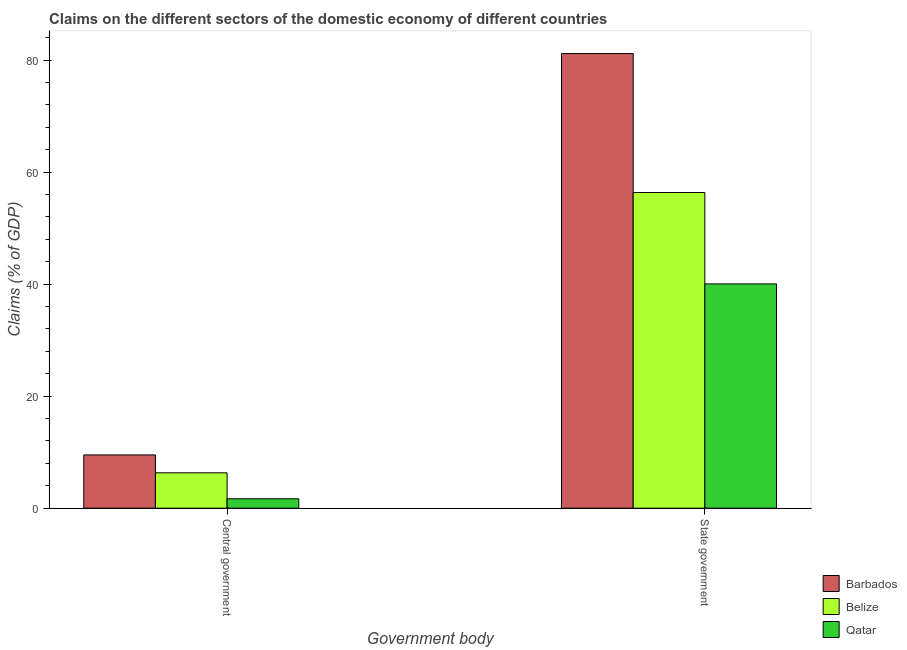Are the number of bars per tick equal to the number of legend labels?
Your answer should be very brief. Yes. How many bars are there on the 2nd tick from the right?
Make the answer very short. 3. What is the label of the 1st group of bars from the left?
Your answer should be very brief. Central government. What is the claims on central government in Qatar?
Ensure brevity in your answer.  1.68. Across all countries, what is the maximum claims on central government?
Your answer should be very brief. 9.51. Across all countries, what is the minimum claims on central government?
Your answer should be compact. 1.68. In which country was the claims on central government maximum?
Keep it short and to the point. Barbados. In which country was the claims on central government minimum?
Keep it short and to the point. Qatar. What is the total claims on state government in the graph?
Offer a terse response. 177.59. What is the difference between the claims on central government in Belize and that in Qatar?
Make the answer very short. 4.64. What is the difference between the claims on central government in Belize and the claims on state government in Barbados?
Your answer should be very brief. -74.86. What is the average claims on central government per country?
Ensure brevity in your answer.  5.84. What is the difference between the claims on state government and claims on central government in Qatar?
Ensure brevity in your answer.  38.37. In how many countries, is the claims on central government greater than 20 %?
Provide a succinct answer. 0. What is the ratio of the claims on state government in Barbados to that in Qatar?
Provide a succinct answer. 2.03. Is the claims on central government in Belize less than that in Qatar?
Ensure brevity in your answer.  No. What does the 1st bar from the left in Central government represents?
Provide a succinct answer. Barbados. What does the 3rd bar from the right in Central government represents?
Keep it short and to the point. Barbados. How many bars are there?
Offer a very short reply. 6. Are all the bars in the graph horizontal?
Your response must be concise. No. What is the difference between two consecutive major ticks on the Y-axis?
Give a very brief answer. 20. Are the values on the major ticks of Y-axis written in scientific E-notation?
Provide a short and direct response. No. Does the graph contain any zero values?
Your response must be concise. No. Where does the legend appear in the graph?
Ensure brevity in your answer.  Bottom right. How many legend labels are there?
Provide a short and direct response. 3. What is the title of the graph?
Your response must be concise. Claims on the different sectors of the domestic economy of different countries. Does "St. Vincent and the Grenadines" appear as one of the legend labels in the graph?
Your answer should be compact. No. What is the label or title of the X-axis?
Offer a very short reply. Government body. What is the label or title of the Y-axis?
Keep it short and to the point. Claims (% of GDP). What is the Claims (% of GDP) in Barbados in Central government?
Offer a terse response. 9.51. What is the Claims (% of GDP) of Belize in Central government?
Provide a succinct answer. 6.32. What is the Claims (% of GDP) in Qatar in Central government?
Provide a short and direct response. 1.68. What is the Claims (% of GDP) of Barbados in State government?
Offer a very short reply. 81.18. What is the Claims (% of GDP) in Belize in State government?
Ensure brevity in your answer.  56.37. What is the Claims (% of GDP) of Qatar in State government?
Your answer should be compact. 40.05. Across all Government body, what is the maximum Claims (% of GDP) in Barbados?
Provide a succinct answer. 81.18. Across all Government body, what is the maximum Claims (% of GDP) in Belize?
Make the answer very short. 56.37. Across all Government body, what is the maximum Claims (% of GDP) of Qatar?
Make the answer very short. 40.05. Across all Government body, what is the minimum Claims (% of GDP) in Barbados?
Offer a very short reply. 9.51. Across all Government body, what is the minimum Claims (% of GDP) in Belize?
Your answer should be compact. 6.32. Across all Government body, what is the minimum Claims (% of GDP) of Qatar?
Offer a terse response. 1.68. What is the total Claims (% of GDP) in Barbados in the graph?
Ensure brevity in your answer.  90.69. What is the total Claims (% of GDP) of Belize in the graph?
Give a very brief answer. 62.69. What is the total Claims (% of GDP) in Qatar in the graph?
Keep it short and to the point. 41.73. What is the difference between the Claims (% of GDP) in Barbados in Central government and that in State government?
Keep it short and to the point. -71.66. What is the difference between the Claims (% of GDP) in Belize in Central government and that in State government?
Offer a very short reply. -50.05. What is the difference between the Claims (% of GDP) of Qatar in Central government and that in State government?
Offer a very short reply. -38.37. What is the difference between the Claims (% of GDP) of Barbados in Central government and the Claims (% of GDP) of Belize in State government?
Give a very brief answer. -46.86. What is the difference between the Claims (% of GDP) in Barbados in Central government and the Claims (% of GDP) in Qatar in State government?
Keep it short and to the point. -30.53. What is the difference between the Claims (% of GDP) of Belize in Central government and the Claims (% of GDP) of Qatar in State government?
Offer a terse response. -33.73. What is the average Claims (% of GDP) in Barbados per Government body?
Provide a short and direct response. 45.34. What is the average Claims (% of GDP) in Belize per Government body?
Give a very brief answer. 31.34. What is the average Claims (% of GDP) in Qatar per Government body?
Offer a terse response. 20.86. What is the difference between the Claims (% of GDP) of Barbados and Claims (% of GDP) of Belize in Central government?
Offer a terse response. 3.2. What is the difference between the Claims (% of GDP) of Barbados and Claims (% of GDP) of Qatar in Central government?
Your answer should be compact. 7.83. What is the difference between the Claims (% of GDP) of Belize and Claims (% of GDP) of Qatar in Central government?
Provide a succinct answer. 4.64. What is the difference between the Claims (% of GDP) of Barbados and Claims (% of GDP) of Belize in State government?
Ensure brevity in your answer.  24.81. What is the difference between the Claims (% of GDP) of Barbados and Claims (% of GDP) of Qatar in State government?
Offer a very short reply. 41.13. What is the difference between the Claims (% of GDP) in Belize and Claims (% of GDP) in Qatar in State government?
Give a very brief answer. 16.32. What is the ratio of the Claims (% of GDP) of Barbados in Central government to that in State government?
Keep it short and to the point. 0.12. What is the ratio of the Claims (% of GDP) in Belize in Central government to that in State government?
Offer a very short reply. 0.11. What is the ratio of the Claims (% of GDP) in Qatar in Central government to that in State government?
Offer a terse response. 0.04. What is the difference between the highest and the second highest Claims (% of GDP) in Barbados?
Ensure brevity in your answer.  71.66. What is the difference between the highest and the second highest Claims (% of GDP) in Belize?
Your answer should be compact. 50.05. What is the difference between the highest and the second highest Claims (% of GDP) in Qatar?
Keep it short and to the point. 38.37. What is the difference between the highest and the lowest Claims (% of GDP) of Barbados?
Offer a terse response. 71.66. What is the difference between the highest and the lowest Claims (% of GDP) of Belize?
Make the answer very short. 50.05. What is the difference between the highest and the lowest Claims (% of GDP) of Qatar?
Ensure brevity in your answer.  38.37. 